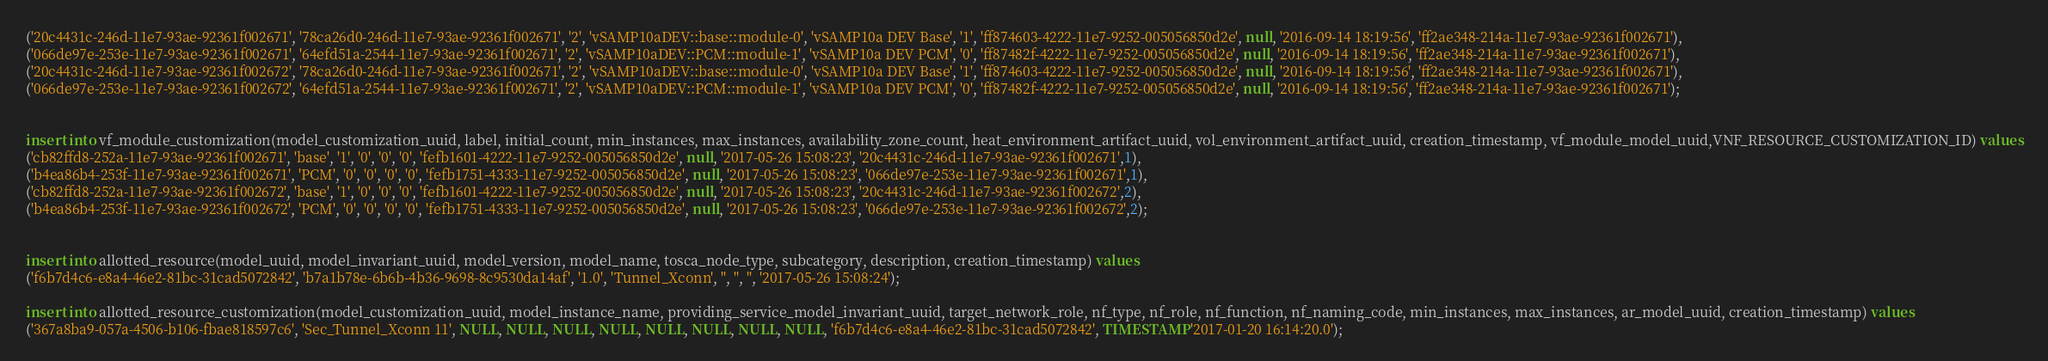<code> <loc_0><loc_0><loc_500><loc_500><_SQL_>('20c4431c-246d-11e7-93ae-92361f002671', '78ca26d0-246d-11e7-93ae-92361f002671', '2', 'vSAMP10aDEV::base::module-0', 'vSAMP10a DEV Base', '1', 'ff874603-4222-11e7-9252-005056850d2e', null, '2016-09-14 18:19:56', 'ff2ae348-214a-11e7-93ae-92361f002671'),
('066de97e-253e-11e7-93ae-92361f002671', '64efd51a-2544-11e7-93ae-92361f002671', '2', 'vSAMP10aDEV::PCM::module-1', 'vSAMP10a DEV PCM', '0', 'ff87482f-4222-11e7-9252-005056850d2e', null, '2016-09-14 18:19:56', 'ff2ae348-214a-11e7-93ae-92361f002671'),
('20c4431c-246d-11e7-93ae-92361f002672', '78ca26d0-246d-11e7-93ae-92361f002671', '2', 'vSAMP10aDEV::base::module-0', 'vSAMP10a DEV Base', '1', 'ff874603-4222-11e7-9252-005056850d2e', null, '2016-09-14 18:19:56', 'ff2ae348-214a-11e7-93ae-92361f002671'),
('066de97e-253e-11e7-93ae-92361f002672', '64efd51a-2544-11e7-93ae-92361f002671', '2', 'vSAMP10aDEV::PCM::module-1', 'vSAMP10a DEV PCM', '0', 'ff87482f-4222-11e7-9252-005056850d2e', null, '2016-09-14 18:19:56', 'ff2ae348-214a-11e7-93ae-92361f002671');


insert into vf_module_customization(model_customization_uuid, label, initial_count, min_instances, max_instances, availability_zone_count, heat_environment_artifact_uuid, vol_environment_artifact_uuid, creation_timestamp, vf_module_model_uuid,VNF_RESOURCE_CUSTOMIZATION_ID) values
('cb82ffd8-252a-11e7-93ae-92361f002671', 'base', '1', '0', '0', '0', 'fefb1601-4222-11e7-9252-005056850d2e', null, '2017-05-26 15:08:23', '20c4431c-246d-11e7-93ae-92361f002671',1),
('b4ea86b4-253f-11e7-93ae-92361f002671', 'PCM', '0', '0', '0', '0', 'fefb1751-4333-11e7-9252-005056850d2e', null, '2017-05-26 15:08:23', '066de97e-253e-11e7-93ae-92361f002671',1),
('cb82ffd8-252a-11e7-93ae-92361f002672', 'base', '1', '0', '0', '0', 'fefb1601-4222-11e7-9252-005056850d2e', null, '2017-05-26 15:08:23', '20c4431c-246d-11e7-93ae-92361f002672',2),
('b4ea86b4-253f-11e7-93ae-92361f002672', 'PCM', '0', '0', '0', '0', 'fefb1751-4333-11e7-9252-005056850d2e', null, '2017-05-26 15:08:23', '066de97e-253e-11e7-93ae-92361f002672',2);


insert into allotted_resource(model_uuid, model_invariant_uuid, model_version, model_name, tosca_node_type, subcategory, description, creation_timestamp) values
('f6b7d4c6-e8a4-46e2-81bc-31cad5072842', 'b7a1b78e-6b6b-4b36-9698-8c9530da14af', '1.0', 'Tunnel_Xconn', '', '', '', '2017-05-26 15:08:24'); 

insert into allotted_resource_customization(model_customization_uuid, model_instance_name, providing_service_model_invariant_uuid, target_network_role, nf_type, nf_role, nf_function, nf_naming_code, min_instances, max_instances, ar_model_uuid, creation_timestamp) values
('367a8ba9-057a-4506-b106-fbae818597c6', 'Sec_Tunnel_Xconn 11', NULL, NULL, NULL, NULL, NULL, NULL, NULL, NULL, 'f6b7d4c6-e8a4-46e2-81bc-31cad5072842', TIMESTAMP '2017-01-20 16:14:20.0');

</code> 